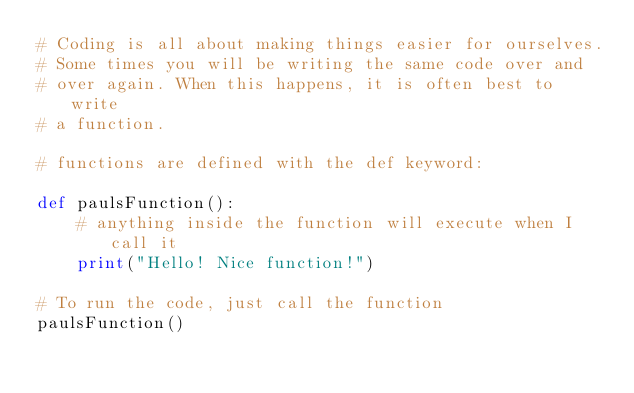Convert code to text. <code><loc_0><loc_0><loc_500><loc_500><_Python_># Coding is all about making things easier for ourselves.
# Some times you will be writing the same code over and 
# over again. When this happens, it is often best to write
# a function.

# functions are defined with the def keyword:

def paulsFunction():
    # anything inside the function will execute when I call it
    print("Hello! Nice function!")

# To run the code, just call the function
paulsFunction()</code> 